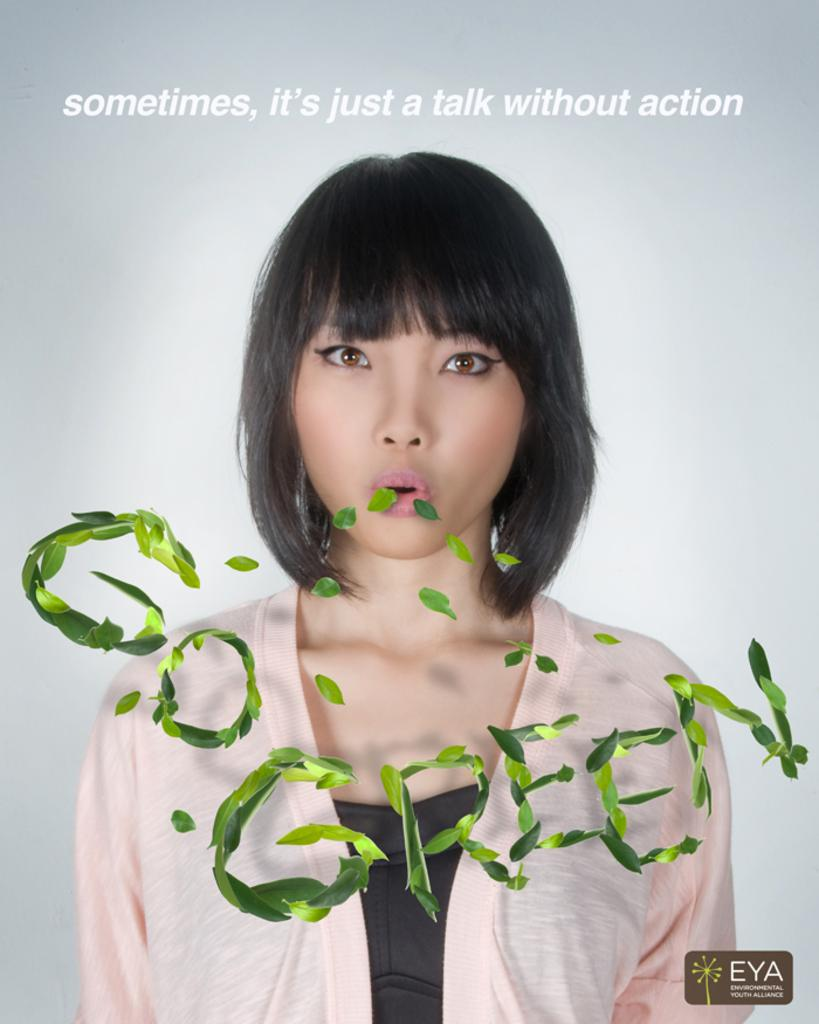Who is the main subject in the image? There is a girl in the center of the center of the image. What is the girl doing in the image? The girl appears to be blowing leaves. Can you describe any additional details about the image? The phrase "go green" is written with leaves in the image. How does the girl twist the bed in the image? There is no bed present in the image, so the girl cannot twist it. 